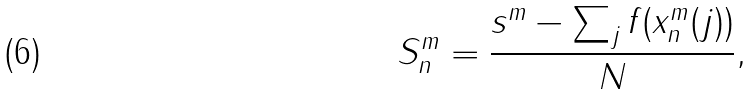Convert formula to latex. <formula><loc_0><loc_0><loc_500><loc_500>S _ { n } ^ { m } = \frac { s ^ { m } - \sum _ { j } f ( x _ { n } ^ { m } ( j ) ) } { N } ,</formula> 